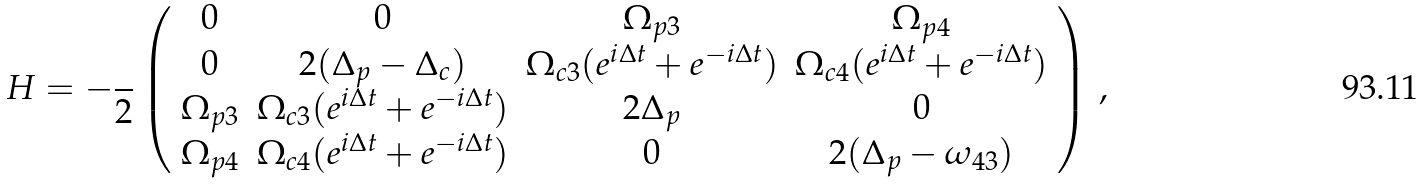Convert formula to latex. <formula><loc_0><loc_0><loc_500><loc_500>H = - \frac { } { 2 } \left ( \begin{array} { c c c c } 0 & 0 & \Omega _ { p 3 } & \Omega _ { p 4 } \\ 0 & 2 ( \Delta _ { p } - \Delta _ { c } ) & \Omega _ { c 3 } ( e ^ { i \Delta t } + e ^ { - i \Delta t } ) & \Omega _ { c 4 } ( e ^ { i \Delta t } + e ^ { - i \Delta t } ) \\ \Omega _ { p 3 } & \Omega _ { c 3 } ( e ^ { i \Delta t } + e ^ { - i \Delta t } ) & 2 \Delta _ { p } & 0 \\ \Omega _ { p 4 } & \Omega _ { c 4 } ( e ^ { i \Delta t } + e ^ { - i \Delta t } ) & 0 & 2 ( \Delta _ { p } - \omega _ { 4 3 } ) \end{array} \right ) \, ,</formula> 